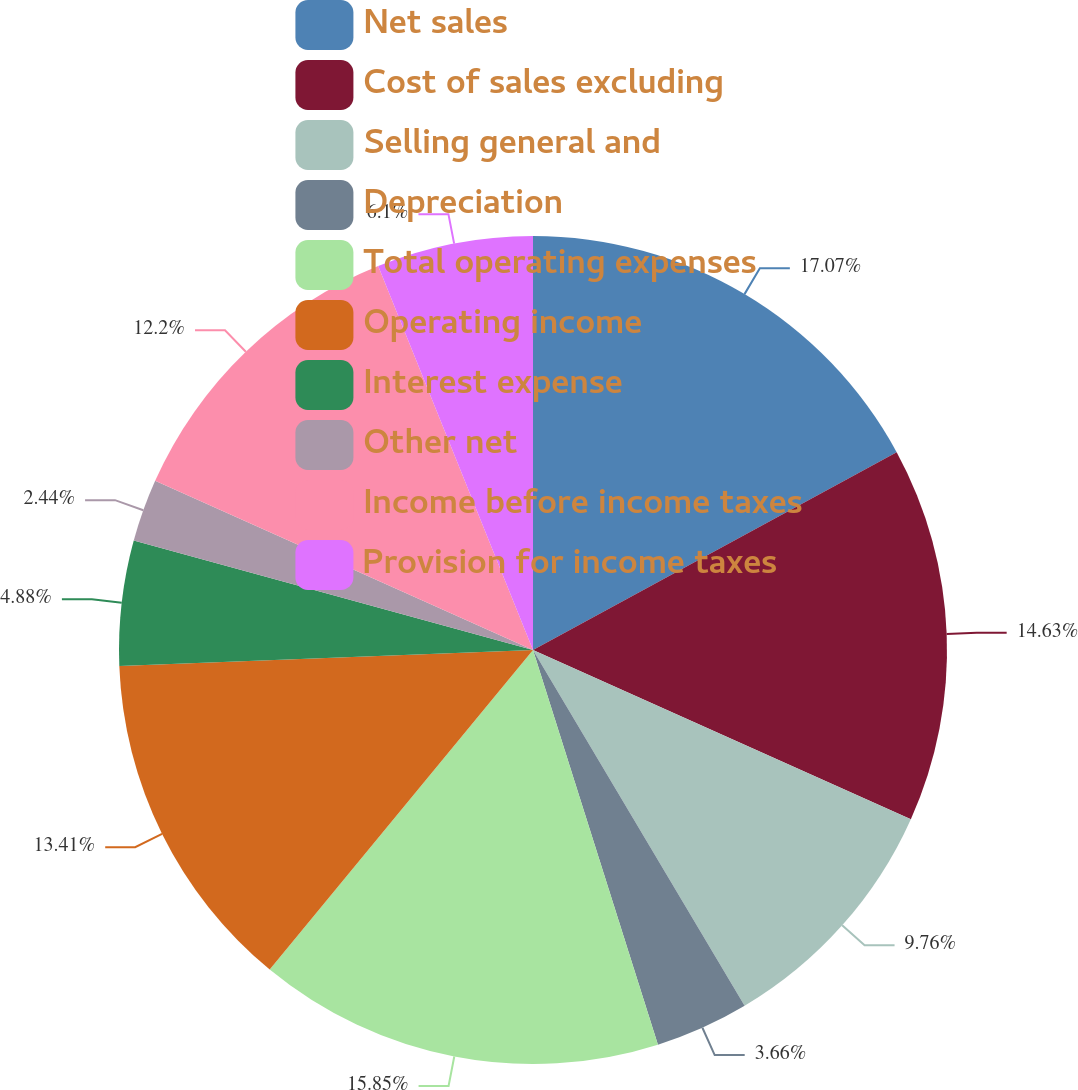Convert chart. <chart><loc_0><loc_0><loc_500><loc_500><pie_chart><fcel>Net sales<fcel>Cost of sales excluding<fcel>Selling general and<fcel>Depreciation<fcel>Total operating expenses<fcel>Operating income<fcel>Interest expense<fcel>Other net<fcel>Income before income taxes<fcel>Provision for income taxes<nl><fcel>17.07%<fcel>14.63%<fcel>9.76%<fcel>3.66%<fcel>15.85%<fcel>13.41%<fcel>4.88%<fcel>2.44%<fcel>12.2%<fcel>6.1%<nl></chart> 